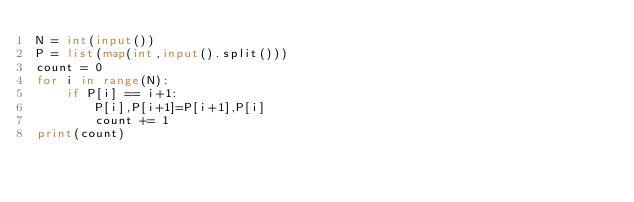Convert code to text. <code><loc_0><loc_0><loc_500><loc_500><_Python_>N = int(input())
P = list(map(int,input().split()))
count = 0
for i in range(N):
    if P[i] == i+1:
        P[i],P[i+1]=P[i+1],P[i]
        count += 1
print(count)</code> 